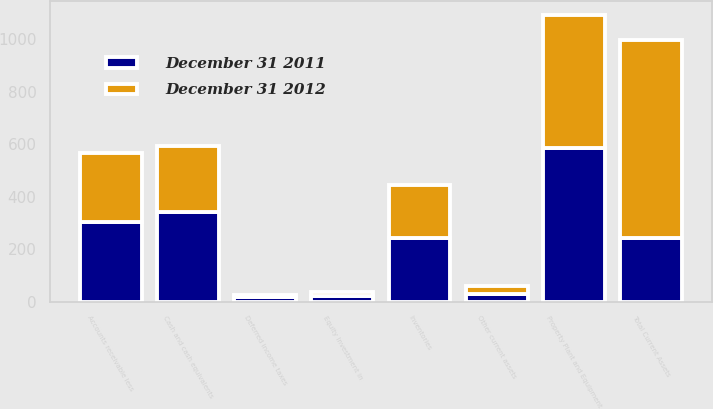Convert chart to OTSL. <chart><loc_0><loc_0><loc_500><loc_500><stacked_bar_chart><ecel><fcel>Cash and cash equivalents<fcel>Accounts receivable less<fcel>Inventories<fcel>Deferred income taxes<fcel>Other current assets<fcel>Total Current Assets<fcel>Property Plant and Equipment<fcel>Equity Investment in<nl><fcel>December 31 2011<fcel>343<fcel>303.1<fcel>242.2<fcel>17.6<fcel>27.9<fcel>242.2<fcel>586<fcel>23<nl><fcel>December 31 2012<fcel>251.4<fcel>264.6<fcel>200.7<fcel>6<fcel>32.5<fcel>755.2<fcel>506<fcel>12<nl></chart> 